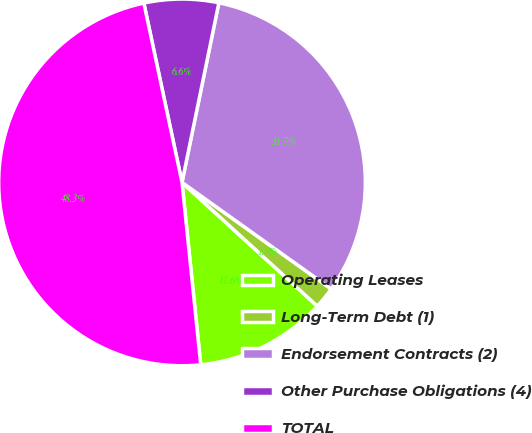<chart> <loc_0><loc_0><loc_500><loc_500><pie_chart><fcel>Operating Leases<fcel>Long-Term Debt (1)<fcel>Endorsement Contracts (2)<fcel>Other Purchase Obligations (4)<fcel>TOTAL<nl><fcel>11.58%<fcel>1.92%<fcel>31.65%<fcel>6.56%<fcel>48.29%<nl></chart> 